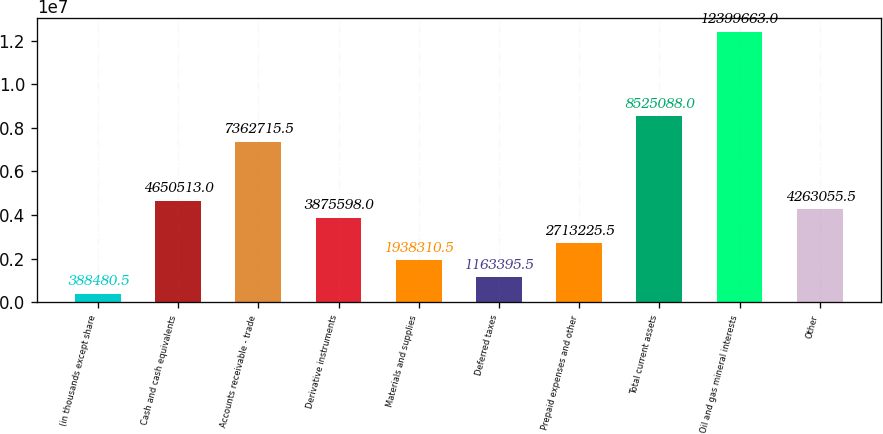<chart> <loc_0><loc_0><loc_500><loc_500><bar_chart><fcel>(in thousands except share<fcel>Cash and cash equivalents<fcel>Accounts receivable - trade<fcel>Derivative instruments<fcel>Materials and supplies<fcel>Deferred taxes<fcel>Prepaid expenses and other<fcel>Total current assets<fcel>Oil and gas mineral interests<fcel>Other<nl><fcel>388480<fcel>4.65051e+06<fcel>7.36272e+06<fcel>3.8756e+06<fcel>1.93831e+06<fcel>1.1634e+06<fcel>2.71323e+06<fcel>8.52509e+06<fcel>1.23997e+07<fcel>4.26306e+06<nl></chart> 